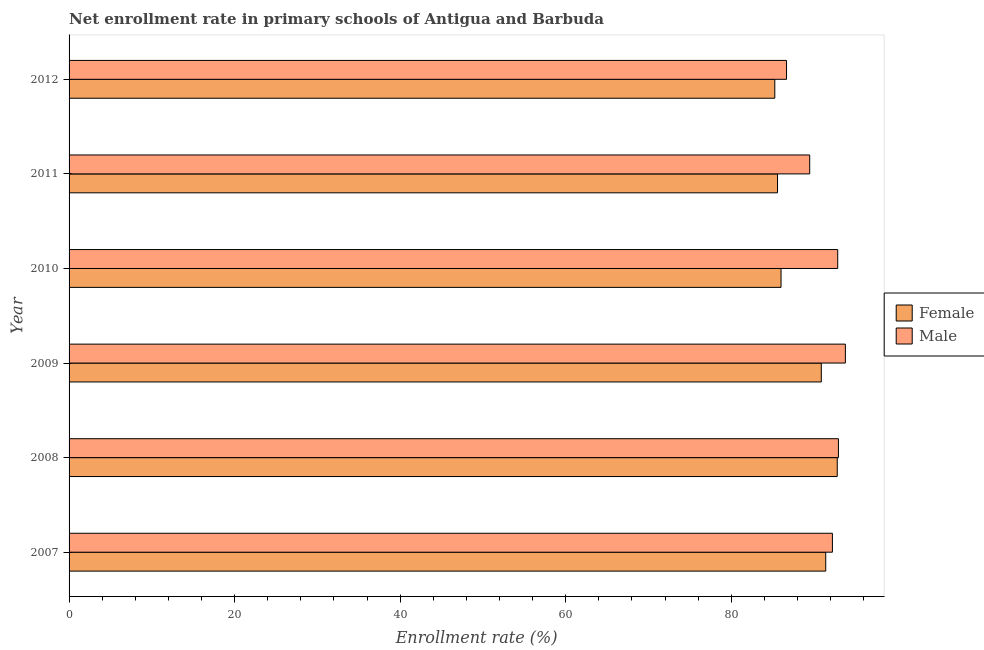How many different coloured bars are there?
Offer a very short reply. 2. How many groups of bars are there?
Offer a very short reply. 6. Are the number of bars on each tick of the Y-axis equal?
Give a very brief answer. Yes. What is the label of the 2nd group of bars from the top?
Provide a short and direct response. 2011. In how many cases, is the number of bars for a given year not equal to the number of legend labels?
Make the answer very short. 0. What is the enrollment rate of female students in 2011?
Your answer should be very brief. 85.59. Across all years, what is the maximum enrollment rate of male students?
Your response must be concise. 93.79. Across all years, what is the minimum enrollment rate of male students?
Your answer should be compact. 86.68. In which year was the enrollment rate of male students maximum?
Your response must be concise. 2009. In which year was the enrollment rate of female students minimum?
Your answer should be compact. 2012. What is the total enrollment rate of male students in the graph?
Provide a succinct answer. 547.98. What is the difference between the enrollment rate of female students in 2009 and that in 2011?
Keep it short and to the point. 5.29. What is the difference between the enrollment rate of male students in 2012 and the enrollment rate of female students in 2007?
Provide a succinct answer. -4.74. What is the average enrollment rate of male students per year?
Make the answer very short. 91.33. In the year 2008, what is the difference between the enrollment rate of male students and enrollment rate of female students?
Ensure brevity in your answer.  0.14. What is the ratio of the enrollment rate of female students in 2008 to that in 2009?
Provide a succinct answer. 1.02. What is the difference between the highest and the second highest enrollment rate of female students?
Your answer should be compact. 1.39. What is the difference between the highest and the lowest enrollment rate of male students?
Offer a very short reply. 7.11. In how many years, is the enrollment rate of female students greater than the average enrollment rate of female students taken over all years?
Your answer should be very brief. 3. How many bars are there?
Ensure brevity in your answer.  12. Are all the bars in the graph horizontal?
Keep it short and to the point. Yes. How many years are there in the graph?
Make the answer very short. 6. Does the graph contain any zero values?
Provide a succinct answer. No. Does the graph contain grids?
Provide a short and direct response. No. What is the title of the graph?
Your answer should be compact. Net enrollment rate in primary schools of Antigua and Barbuda. What is the label or title of the X-axis?
Make the answer very short. Enrollment rate (%). What is the Enrollment rate (%) of Female in 2007?
Your answer should be compact. 91.42. What is the Enrollment rate (%) of Male in 2007?
Give a very brief answer. 92.22. What is the Enrollment rate (%) in Female in 2008?
Offer a very short reply. 92.81. What is the Enrollment rate (%) in Male in 2008?
Your answer should be very brief. 92.95. What is the Enrollment rate (%) in Female in 2009?
Your response must be concise. 90.88. What is the Enrollment rate (%) of Male in 2009?
Your answer should be compact. 93.79. What is the Enrollment rate (%) in Female in 2010?
Offer a very short reply. 86.01. What is the Enrollment rate (%) in Male in 2010?
Provide a succinct answer. 92.86. What is the Enrollment rate (%) of Female in 2011?
Offer a very short reply. 85.59. What is the Enrollment rate (%) of Male in 2011?
Ensure brevity in your answer.  89.48. What is the Enrollment rate (%) in Female in 2012?
Provide a short and direct response. 85.26. What is the Enrollment rate (%) in Male in 2012?
Provide a succinct answer. 86.68. Across all years, what is the maximum Enrollment rate (%) in Female?
Offer a very short reply. 92.81. Across all years, what is the maximum Enrollment rate (%) of Male?
Offer a terse response. 93.79. Across all years, what is the minimum Enrollment rate (%) of Female?
Your answer should be very brief. 85.26. Across all years, what is the minimum Enrollment rate (%) in Male?
Offer a very short reply. 86.68. What is the total Enrollment rate (%) in Female in the graph?
Provide a succinct answer. 531.97. What is the total Enrollment rate (%) in Male in the graph?
Make the answer very short. 547.98. What is the difference between the Enrollment rate (%) of Female in 2007 and that in 2008?
Your answer should be very brief. -1.39. What is the difference between the Enrollment rate (%) in Male in 2007 and that in 2008?
Give a very brief answer. -0.73. What is the difference between the Enrollment rate (%) in Female in 2007 and that in 2009?
Make the answer very short. 0.54. What is the difference between the Enrollment rate (%) in Male in 2007 and that in 2009?
Keep it short and to the point. -1.57. What is the difference between the Enrollment rate (%) of Female in 2007 and that in 2010?
Provide a short and direct response. 5.4. What is the difference between the Enrollment rate (%) in Male in 2007 and that in 2010?
Keep it short and to the point. -0.64. What is the difference between the Enrollment rate (%) of Female in 2007 and that in 2011?
Offer a terse response. 5.82. What is the difference between the Enrollment rate (%) in Male in 2007 and that in 2011?
Give a very brief answer. 2.74. What is the difference between the Enrollment rate (%) of Female in 2007 and that in 2012?
Ensure brevity in your answer.  6.15. What is the difference between the Enrollment rate (%) in Male in 2007 and that in 2012?
Make the answer very short. 5.54. What is the difference between the Enrollment rate (%) in Female in 2008 and that in 2009?
Provide a short and direct response. 1.93. What is the difference between the Enrollment rate (%) in Male in 2008 and that in 2009?
Offer a terse response. -0.84. What is the difference between the Enrollment rate (%) of Female in 2008 and that in 2010?
Provide a short and direct response. 6.79. What is the difference between the Enrollment rate (%) in Male in 2008 and that in 2010?
Make the answer very short. 0.09. What is the difference between the Enrollment rate (%) of Female in 2008 and that in 2011?
Your answer should be very brief. 7.21. What is the difference between the Enrollment rate (%) in Male in 2008 and that in 2011?
Offer a terse response. 3.47. What is the difference between the Enrollment rate (%) of Female in 2008 and that in 2012?
Ensure brevity in your answer.  7.54. What is the difference between the Enrollment rate (%) of Male in 2008 and that in 2012?
Make the answer very short. 6.27. What is the difference between the Enrollment rate (%) in Female in 2009 and that in 2010?
Your answer should be compact. 4.87. What is the difference between the Enrollment rate (%) in Male in 2009 and that in 2010?
Give a very brief answer. 0.92. What is the difference between the Enrollment rate (%) of Female in 2009 and that in 2011?
Provide a succinct answer. 5.29. What is the difference between the Enrollment rate (%) in Male in 2009 and that in 2011?
Ensure brevity in your answer.  4.31. What is the difference between the Enrollment rate (%) of Female in 2009 and that in 2012?
Give a very brief answer. 5.62. What is the difference between the Enrollment rate (%) of Male in 2009 and that in 2012?
Make the answer very short. 7.11. What is the difference between the Enrollment rate (%) of Female in 2010 and that in 2011?
Make the answer very short. 0.42. What is the difference between the Enrollment rate (%) of Male in 2010 and that in 2011?
Provide a short and direct response. 3.39. What is the difference between the Enrollment rate (%) in Female in 2010 and that in 2012?
Make the answer very short. 0.75. What is the difference between the Enrollment rate (%) in Male in 2010 and that in 2012?
Offer a very short reply. 6.18. What is the difference between the Enrollment rate (%) of Female in 2011 and that in 2012?
Keep it short and to the point. 0.33. What is the difference between the Enrollment rate (%) in Male in 2011 and that in 2012?
Your answer should be compact. 2.8. What is the difference between the Enrollment rate (%) in Female in 2007 and the Enrollment rate (%) in Male in 2008?
Provide a succinct answer. -1.54. What is the difference between the Enrollment rate (%) in Female in 2007 and the Enrollment rate (%) in Male in 2009?
Your answer should be very brief. -2.37. What is the difference between the Enrollment rate (%) of Female in 2007 and the Enrollment rate (%) of Male in 2010?
Keep it short and to the point. -1.45. What is the difference between the Enrollment rate (%) in Female in 2007 and the Enrollment rate (%) in Male in 2011?
Offer a very short reply. 1.94. What is the difference between the Enrollment rate (%) of Female in 2007 and the Enrollment rate (%) of Male in 2012?
Ensure brevity in your answer.  4.74. What is the difference between the Enrollment rate (%) in Female in 2008 and the Enrollment rate (%) in Male in 2009?
Give a very brief answer. -0.98. What is the difference between the Enrollment rate (%) in Female in 2008 and the Enrollment rate (%) in Male in 2010?
Keep it short and to the point. -0.06. What is the difference between the Enrollment rate (%) of Female in 2008 and the Enrollment rate (%) of Male in 2011?
Your response must be concise. 3.33. What is the difference between the Enrollment rate (%) in Female in 2008 and the Enrollment rate (%) in Male in 2012?
Make the answer very short. 6.13. What is the difference between the Enrollment rate (%) of Female in 2009 and the Enrollment rate (%) of Male in 2010?
Keep it short and to the point. -1.98. What is the difference between the Enrollment rate (%) of Female in 2009 and the Enrollment rate (%) of Male in 2011?
Your answer should be very brief. 1.4. What is the difference between the Enrollment rate (%) of Female in 2009 and the Enrollment rate (%) of Male in 2012?
Give a very brief answer. 4.2. What is the difference between the Enrollment rate (%) in Female in 2010 and the Enrollment rate (%) in Male in 2011?
Offer a terse response. -3.46. What is the difference between the Enrollment rate (%) of Female in 2010 and the Enrollment rate (%) of Male in 2012?
Keep it short and to the point. -0.67. What is the difference between the Enrollment rate (%) in Female in 2011 and the Enrollment rate (%) in Male in 2012?
Your answer should be very brief. -1.09. What is the average Enrollment rate (%) in Female per year?
Keep it short and to the point. 88.66. What is the average Enrollment rate (%) of Male per year?
Ensure brevity in your answer.  91.33. In the year 2007, what is the difference between the Enrollment rate (%) of Female and Enrollment rate (%) of Male?
Your response must be concise. -0.81. In the year 2008, what is the difference between the Enrollment rate (%) in Female and Enrollment rate (%) in Male?
Provide a short and direct response. -0.14. In the year 2009, what is the difference between the Enrollment rate (%) of Female and Enrollment rate (%) of Male?
Your answer should be very brief. -2.91. In the year 2010, what is the difference between the Enrollment rate (%) in Female and Enrollment rate (%) in Male?
Offer a very short reply. -6.85. In the year 2011, what is the difference between the Enrollment rate (%) in Female and Enrollment rate (%) in Male?
Your answer should be very brief. -3.89. In the year 2012, what is the difference between the Enrollment rate (%) in Female and Enrollment rate (%) in Male?
Keep it short and to the point. -1.42. What is the ratio of the Enrollment rate (%) of Female in 2007 to that in 2008?
Keep it short and to the point. 0.98. What is the ratio of the Enrollment rate (%) of Male in 2007 to that in 2008?
Give a very brief answer. 0.99. What is the ratio of the Enrollment rate (%) of Female in 2007 to that in 2009?
Your response must be concise. 1.01. What is the ratio of the Enrollment rate (%) of Male in 2007 to that in 2009?
Your answer should be very brief. 0.98. What is the ratio of the Enrollment rate (%) in Female in 2007 to that in 2010?
Keep it short and to the point. 1.06. What is the ratio of the Enrollment rate (%) in Male in 2007 to that in 2010?
Give a very brief answer. 0.99. What is the ratio of the Enrollment rate (%) of Female in 2007 to that in 2011?
Your response must be concise. 1.07. What is the ratio of the Enrollment rate (%) in Male in 2007 to that in 2011?
Offer a very short reply. 1.03. What is the ratio of the Enrollment rate (%) in Female in 2007 to that in 2012?
Ensure brevity in your answer.  1.07. What is the ratio of the Enrollment rate (%) in Male in 2007 to that in 2012?
Provide a short and direct response. 1.06. What is the ratio of the Enrollment rate (%) in Female in 2008 to that in 2009?
Provide a short and direct response. 1.02. What is the ratio of the Enrollment rate (%) in Male in 2008 to that in 2009?
Your answer should be very brief. 0.99. What is the ratio of the Enrollment rate (%) in Female in 2008 to that in 2010?
Your answer should be compact. 1.08. What is the ratio of the Enrollment rate (%) in Male in 2008 to that in 2010?
Offer a very short reply. 1. What is the ratio of the Enrollment rate (%) in Female in 2008 to that in 2011?
Your answer should be very brief. 1.08. What is the ratio of the Enrollment rate (%) of Male in 2008 to that in 2011?
Your response must be concise. 1.04. What is the ratio of the Enrollment rate (%) of Female in 2008 to that in 2012?
Offer a terse response. 1.09. What is the ratio of the Enrollment rate (%) in Male in 2008 to that in 2012?
Your answer should be compact. 1.07. What is the ratio of the Enrollment rate (%) of Female in 2009 to that in 2010?
Provide a succinct answer. 1.06. What is the ratio of the Enrollment rate (%) of Male in 2009 to that in 2010?
Your answer should be very brief. 1.01. What is the ratio of the Enrollment rate (%) of Female in 2009 to that in 2011?
Give a very brief answer. 1.06. What is the ratio of the Enrollment rate (%) in Male in 2009 to that in 2011?
Ensure brevity in your answer.  1.05. What is the ratio of the Enrollment rate (%) in Female in 2009 to that in 2012?
Ensure brevity in your answer.  1.07. What is the ratio of the Enrollment rate (%) of Male in 2009 to that in 2012?
Make the answer very short. 1.08. What is the ratio of the Enrollment rate (%) in Male in 2010 to that in 2011?
Offer a terse response. 1.04. What is the ratio of the Enrollment rate (%) in Female in 2010 to that in 2012?
Provide a succinct answer. 1.01. What is the ratio of the Enrollment rate (%) of Male in 2010 to that in 2012?
Provide a succinct answer. 1.07. What is the ratio of the Enrollment rate (%) in Male in 2011 to that in 2012?
Your response must be concise. 1.03. What is the difference between the highest and the second highest Enrollment rate (%) in Female?
Provide a succinct answer. 1.39. What is the difference between the highest and the second highest Enrollment rate (%) in Male?
Offer a terse response. 0.84. What is the difference between the highest and the lowest Enrollment rate (%) of Female?
Offer a very short reply. 7.54. What is the difference between the highest and the lowest Enrollment rate (%) in Male?
Ensure brevity in your answer.  7.11. 